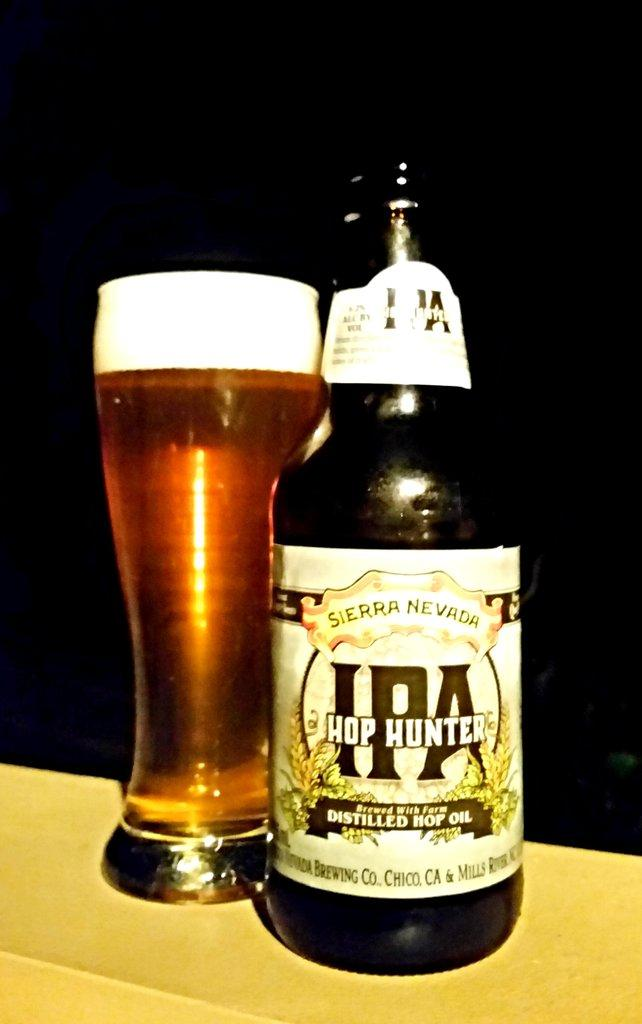<image>
Create a compact narrative representing the image presented. The brand of beer is from the company Sierra Nevada 